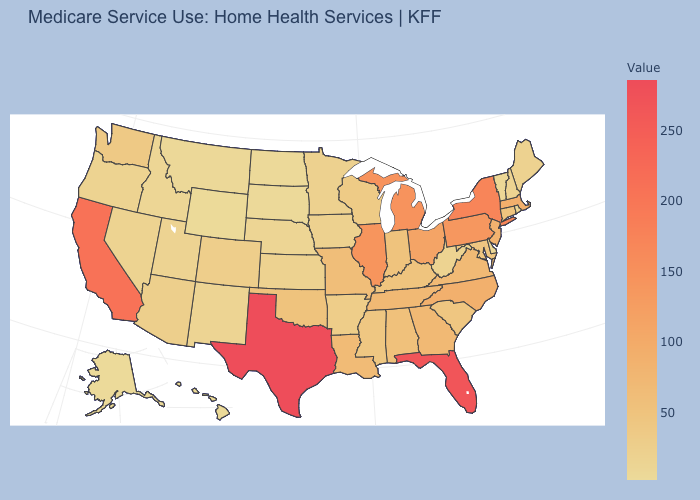Does California have the highest value in the West?
Answer briefly. Yes. Which states have the highest value in the USA?
Short answer required. Texas. Is the legend a continuous bar?
Be succinct. Yes. Among the states that border Oregon , which have the highest value?
Keep it brief. California. Does Texas have the highest value in the USA?
Keep it brief. Yes. Among the states that border South Carolina , which have the lowest value?
Write a very short answer. Georgia. 